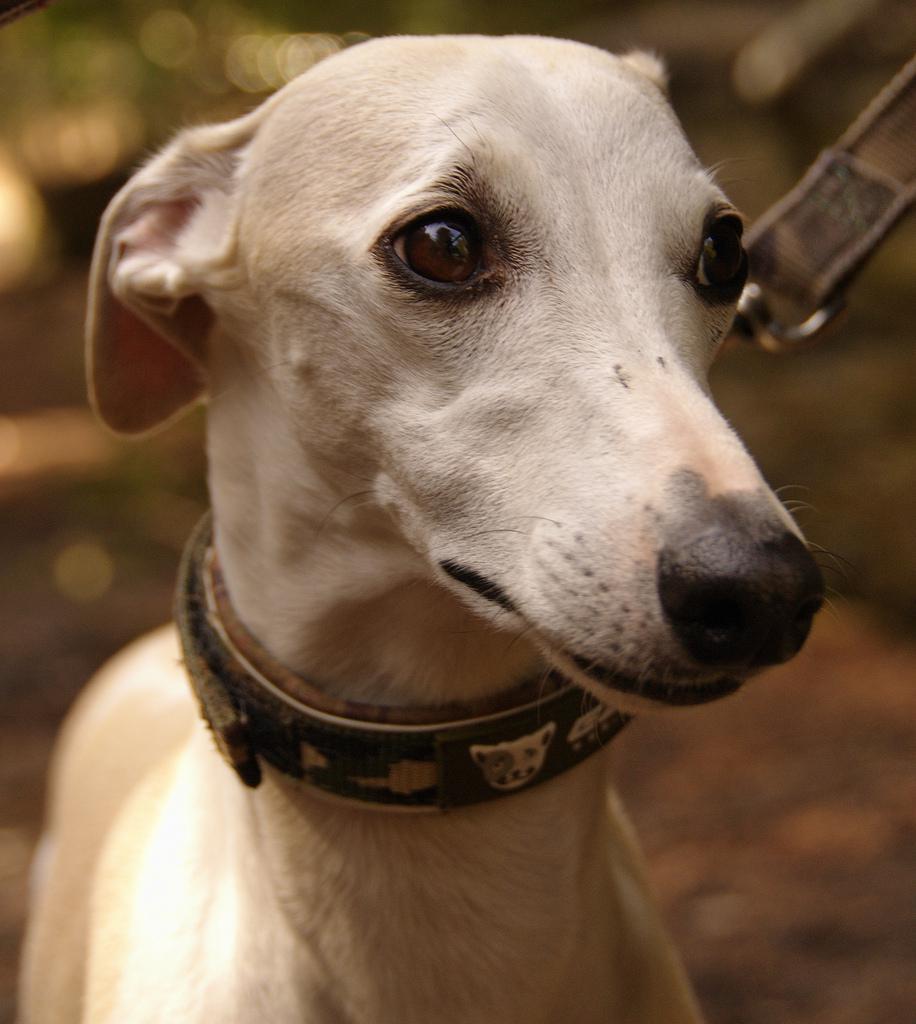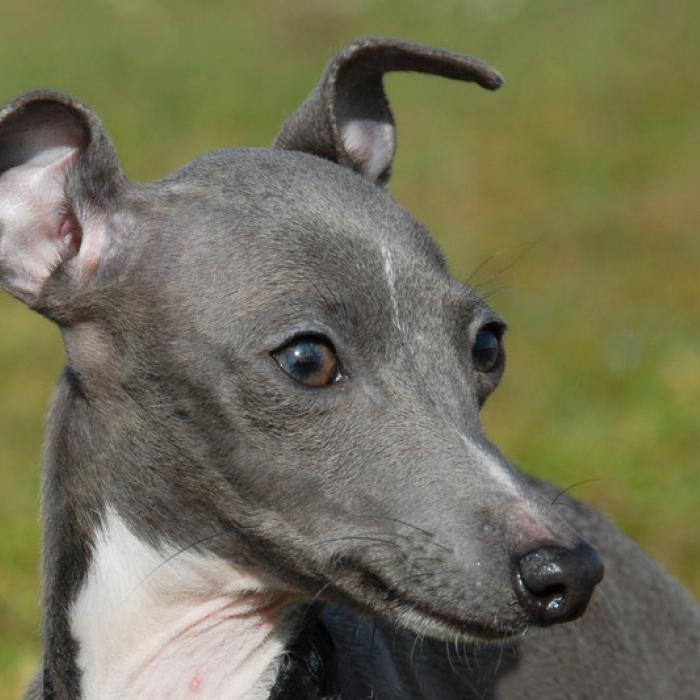The first image is the image on the left, the second image is the image on the right. For the images displayed, is the sentence "The dog in the image on the left is wearing a collar." factually correct? Answer yes or no. Yes. 